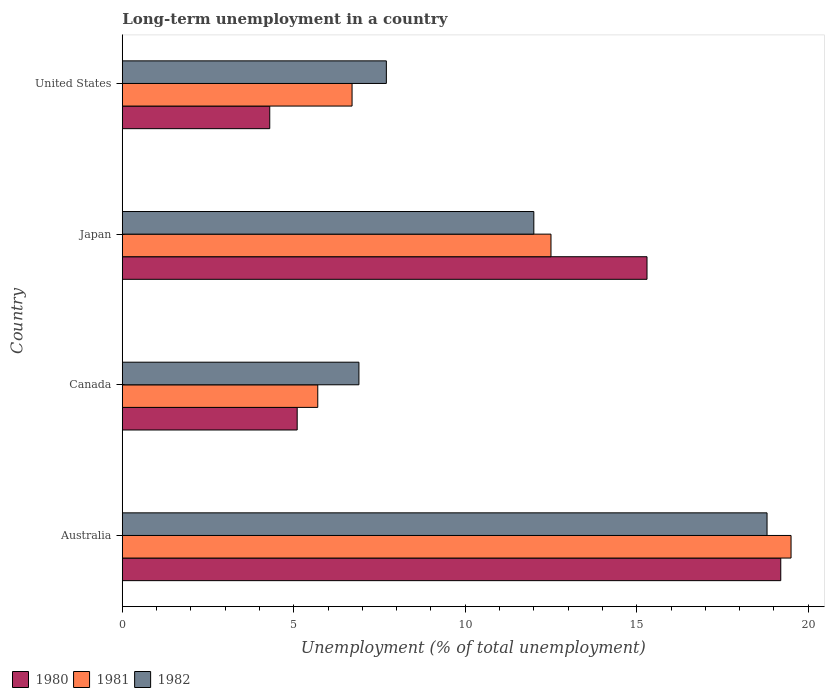How many groups of bars are there?
Provide a succinct answer. 4. Are the number of bars per tick equal to the number of legend labels?
Your answer should be compact. Yes. Are the number of bars on each tick of the Y-axis equal?
Your answer should be compact. Yes. How many bars are there on the 1st tick from the bottom?
Give a very brief answer. 3. What is the percentage of long-term unemployed population in 1980 in Japan?
Provide a short and direct response. 15.3. Across all countries, what is the maximum percentage of long-term unemployed population in 1980?
Offer a terse response. 19.2. Across all countries, what is the minimum percentage of long-term unemployed population in 1982?
Your answer should be very brief. 6.9. In which country was the percentage of long-term unemployed population in 1982 maximum?
Your response must be concise. Australia. What is the total percentage of long-term unemployed population in 1981 in the graph?
Give a very brief answer. 44.4. What is the difference between the percentage of long-term unemployed population in 1981 in Canada and that in United States?
Give a very brief answer. -1. What is the difference between the percentage of long-term unemployed population in 1982 in Japan and the percentage of long-term unemployed population in 1980 in United States?
Offer a terse response. 7.7. What is the average percentage of long-term unemployed population in 1980 per country?
Provide a short and direct response. 10.98. What is the difference between the percentage of long-term unemployed population in 1981 and percentage of long-term unemployed population in 1980 in Australia?
Provide a succinct answer. 0.3. In how many countries, is the percentage of long-term unemployed population in 1980 greater than 13 %?
Provide a succinct answer. 2. What is the ratio of the percentage of long-term unemployed population in 1981 in Australia to that in Japan?
Make the answer very short. 1.56. Is the difference between the percentage of long-term unemployed population in 1981 in Canada and United States greater than the difference between the percentage of long-term unemployed population in 1980 in Canada and United States?
Provide a short and direct response. No. What is the difference between the highest and the second highest percentage of long-term unemployed population in 1982?
Ensure brevity in your answer.  6.8. What is the difference between the highest and the lowest percentage of long-term unemployed population in 1982?
Offer a terse response. 11.9. How many bars are there?
Provide a short and direct response. 12. Are all the bars in the graph horizontal?
Provide a succinct answer. Yes. How many countries are there in the graph?
Provide a succinct answer. 4. Where does the legend appear in the graph?
Provide a succinct answer. Bottom left. How many legend labels are there?
Your response must be concise. 3. What is the title of the graph?
Ensure brevity in your answer.  Long-term unemployment in a country. What is the label or title of the X-axis?
Provide a succinct answer. Unemployment (% of total unemployment). What is the label or title of the Y-axis?
Offer a terse response. Country. What is the Unemployment (% of total unemployment) of 1980 in Australia?
Give a very brief answer. 19.2. What is the Unemployment (% of total unemployment) of 1982 in Australia?
Give a very brief answer. 18.8. What is the Unemployment (% of total unemployment) of 1980 in Canada?
Keep it short and to the point. 5.1. What is the Unemployment (% of total unemployment) in 1981 in Canada?
Offer a terse response. 5.7. What is the Unemployment (% of total unemployment) of 1982 in Canada?
Make the answer very short. 6.9. What is the Unemployment (% of total unemployment) of 1980 in Japan?
Your response must be concise. 15.3. What is the Unemployment (% of total unemployment) of 1981 in Japan?
Ensure brevity in your answer.  12.5. What is the Unemployment (% of total unemployment) in 1980 in United States?
Your answer should be compact. 4.3. What is the Unemployment (% of total unemployment) of 1981 in United States?
Provide a short and direct response. 6.7. What is the Unemployment (% of total unemployment) of 1982 in United States?
Your answer should be compact. 7.7. Across all countries, what is the maximum Unemployment (% of total unemployment) of 1980?
Offer a very short reply. 19.2. Across all countries, what is the maximum Unemployment (% of total unemployment) of 1981?
Offer a very short reply. 19.5. Across all countries, what is the maximum Unemployment (% of total unemployment) of 1982?
Your answer should be very brief. 18.8. Across all countries, what is the minimum Unemployment (% of total unemployment) in 1980?
Make the answer very short. 4.3. Across all countries, what is the minimum Unemployment (% of total unemployment) of 1981?
Make the answer very short. 5.7. Across all countries, what is the minimum Unemployment (% of total unemployment) of 1982?
Provide a short and direct response. 6.9. What is the total Unemployment (% of total unemployment) in 1980 in the graph?
Make the answer very short. 43.9. What is the total Unemployment (% of total unemployment) in 1981 in the graph?
Ensure brevity in your answer.  44.4. What is the total Unemployment (% of total unemployment) of 1982 in the graph?
Ensure brevity in your answer.  45.4. What is the difference between the Unemployment (% of total unemployment) of 1981 in Australia and that in Canada?
Make the answer very short. 13.8. What is the difference between the Unemployment (% of total unemployment) in 1980 in Australia and that in United States?
Ensure brevity in your answer.  14.9. What is the difference between the Unemployment (% of total unemployment) of 1981 in Australia and that in United States?
Keep it short and to the point. 12.8. What is the difference between the Unemployment (% of total unemployment) of 1982 in Canada and that in Japan?
Make the answer very short. -5.1. What is the difference between the Unemployment (% of total unemployment) of 1980 in Canada and that in United States?
Provide a succinct answer. 0.8. What is the difference between the Unemployment (% of total unemployment) in 1982 in Canada and that in United States?
Make the answer very short. -0.8. What is the difference between the Unemployment (% of total unemployment) of 1980 in Japan and that in United States?
Your answer should be very brief. 11. What is the difference between the Unemployment (% of total unemployment) of 1980 in Australia and the Unemployment (% of total unemployment) of 1981 in Japan?
Provide a short and direct response. 6.7. What is the difference between the Unemployment (% of total unemployment) of 1981 in Australia and the Unemployment (% of total unemployment) of 1982 in Japan?
Your response must be concise. 7.5. What is the difference between the Unemployment (% of total unemployment) of 1981 in Australia and the Unemployment (% of total unemployment) of 1982 in United States?
Make the answer very short. 11.8. What is the difference between the Unemployment (% of total unemployment) of 1980 in Canada and the Unemployment (% of total unemployment) of 1982 in Japan?
Offer a terse response. -6.9. What is the difference between the Unemployment (% of total unemployment) of 1980 in Canada and the Unemployment (% of total unemployment) of 1981 in United States?
Your answer should be compact. -1.6. What is the difference between the Unemployment (% of total unemployment) of 1980 in Canada and the Unemployment (% of total unemployment) of 1982 in United States?
Provide a succinct answer. -2.6. What is the difference between the Unemployment (% of total unemployment) in 1980 in Japan and the Unemployment (% of total unemployment) in 1981 in United States?
Keep it short and to the point. 8.6. What is the difference between the Unemployment (% of total unemployment) in 1980 in Japan and the Unemployment (% of total unemployment) in 1982 in United States?
Ensure brevity in your answer.  7.6. What is the average Unemployment (% of total unemployment) of 1980 per country?
Provide a short and direct response. 10.97. What is the average Unemployment (% of total unemployment) in 1981 per country?
Offer a very short reply. 11.1. What is the average Unemployment (% of total unemployment) of 1982 per country?
Keep it short and to the point. 11.35. What is the difference between the Unemployment (% of total unemployment) in 1980 and Unemployment (% of total unemployment) in 1982 in Australia?
Your response must be concise. 0.4. What is the difference between the Unemployment (% of total unemployment) of 1981 and Unemployment (% of total unemployment) of 1982 in Australia?
Offer a very short reply. 0.7. What is the difference between the Unemployment (% of total unemployment) of 1980 and Unemployment (% of total unemployment) of 1981 in Canada?
Your response must be concise. -0.6. What is the difference between the Unemployment (% of total unemployment) of 1981 and Unemployment (% of total unemployment) of 1982 in Japan?
Ensure brevity in your answer.  0.5. What is the difference between the Unemployment (% of total unemployment) of 1980 and Unemployment (% of total unemployment) of 1981 in United States?
Ensure brevity in your answer.  -2.4. What is the difference between the Unemployment (% of total unemployment) in 1980 and Unemployment (% of total unemployment) in 1982 in United States?
Your answer should be compact. -3.4. What is the ratio of the Unemployment (% of total unemployment) in 1980 in Australia to that in Canada?
Make the answer very short. 3.76. What is the ratio of the Unemployment (% of total unemployment) in 1981 in Australia to that in Canada?
Your answer should be very brief. 3.42. What is the ratio of the Unemployment (% of total unemployment) of 1982 in Australia to that in Canada?
Your answer should be compact. 2.72. What is the ratio of the Unemployment (% of total unemployment) in 1980 in Australia to that in Japan?
Your answer should be compact. 1.25. What is the ratio of the Unemployment (% of total unemployment) in 1981 in Australia to that in Japan?
Keep it short and to the point. 1.56. What is the ratio of the Unemployment (% of total unemployment) of 1982 in Australia to that in Japan?
Ensure brevity in your answer.  1.57. What is the ratio of the Unemployment (% of total unemployment) in 1980 in Australia to that in United States?
Ensure brevity in your answer.  4.47. What is the ratio of the Unemployment (% of total unemployment) of 1981 in Australia to that in United States?
Ensure brevity in your answer.  2.91. What is the ratio of the Unemployment (% of total unemployment) of 1982 in Australia to that in United States?
Keep it short and to the point. 2.44. What is the ratio of the Unemployment (% of total unemployment) of 1981 in Canada to that in Japan?
Ensure brevity in your answer.  0.46. What is the ratio of the Unemployment (% of total unemployment) in 1982 in Canada to that in Japan?
Give a very brief answer. 0.57. What is the ratio of the Unemployment (% of total unemployment) of 1980 in Canada to that in United States?
Provide a succinct answer. 1.19. What is the ratio of the Unemployment (% of total unemployment) of 1981 in Canada to that in United States?
Offer a very short reply. 0.85. What is the ratio of the Unemployment (% of total unemployment) of 1982 in Canada to that in United States?
Ensure brevity in your answer.  0.9. What is the ratio of the Unemployment (% of total unemployment) of 1980 in Japan to that in United States?
Offer a terse response. 3.56. What is the ratio of the Unemployment (% of total unemployment) in 1981 in Japan to that in United States?
Offer a terse response. 1.87. What is the ratio of the Unemployment (% of total unemployment) in 1982 in Japan to that in United States?
Your response must be concise. 1.56. What is the difference between the highest and the second highest Unemployment (% of total unemployment) in 1982?
Provide a succinct answer. 6.8. What is the difference between the highest and the lowest Unemployment (% of total unemployment) of 1981?
Your response must be concise. 13.8. What is the difference between the highest and the lowest Unemployment (% of total unemployment) in 1982?
Offer a terse response. 11.9. 